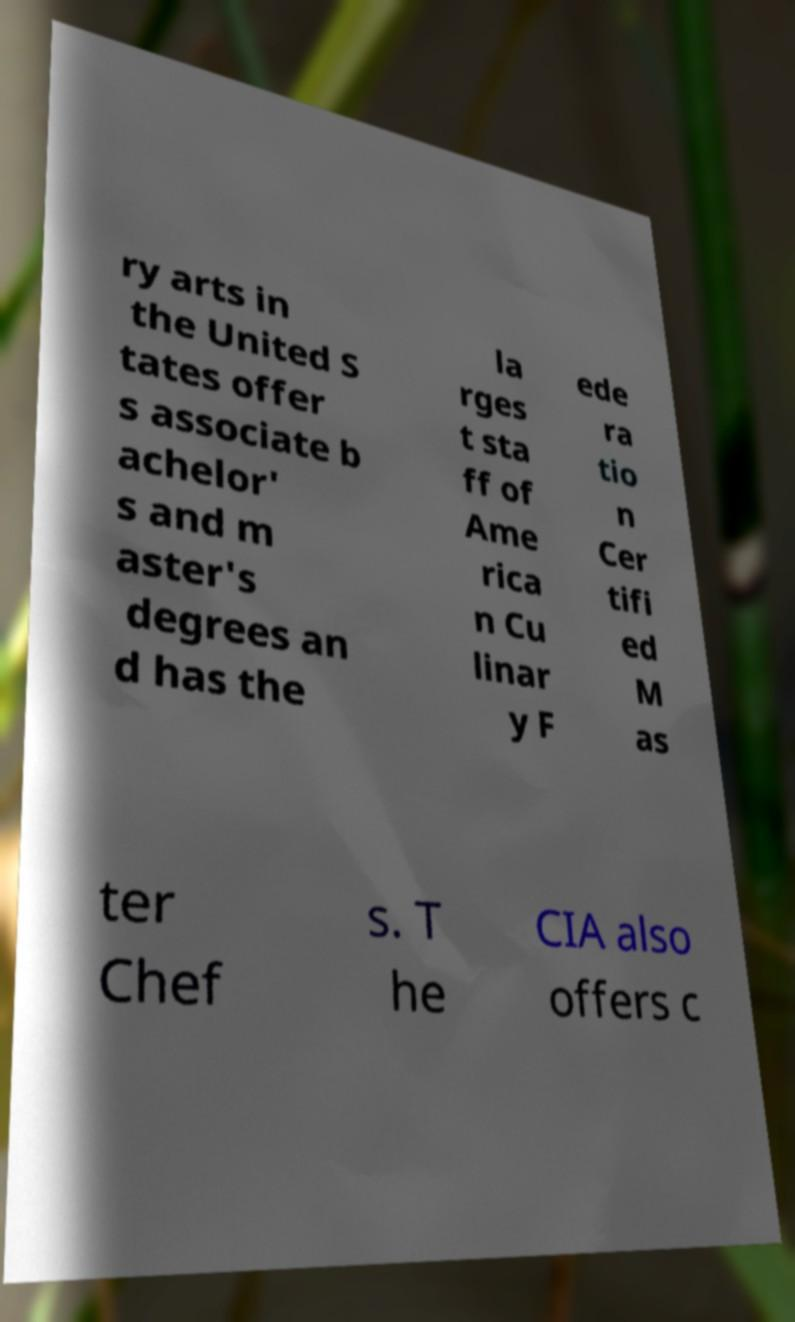For documentation purposes, I need the text within this image transcribed. Could you provide that? ry arts in the United S tates offer s associate b achelor' s and m aster's degrees an d has the la rges t sta ff of Ame rica n Cu linar y F ede ra tio n Cer tifi ed M as ter Chef s. T he CIA also offers c 